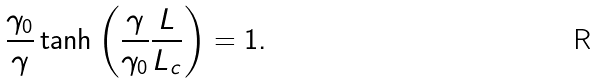Convert formula to latex. <formula><loc_0><loc_0><loc_500><loc_500>\frac { \gamma _ { 0 } } { \gamma } \tanh \left ( \frac { \gamma } { \gamma _ { 0 } } \frac { L } { L _ { c } } \right ) = 1 .</formula> 